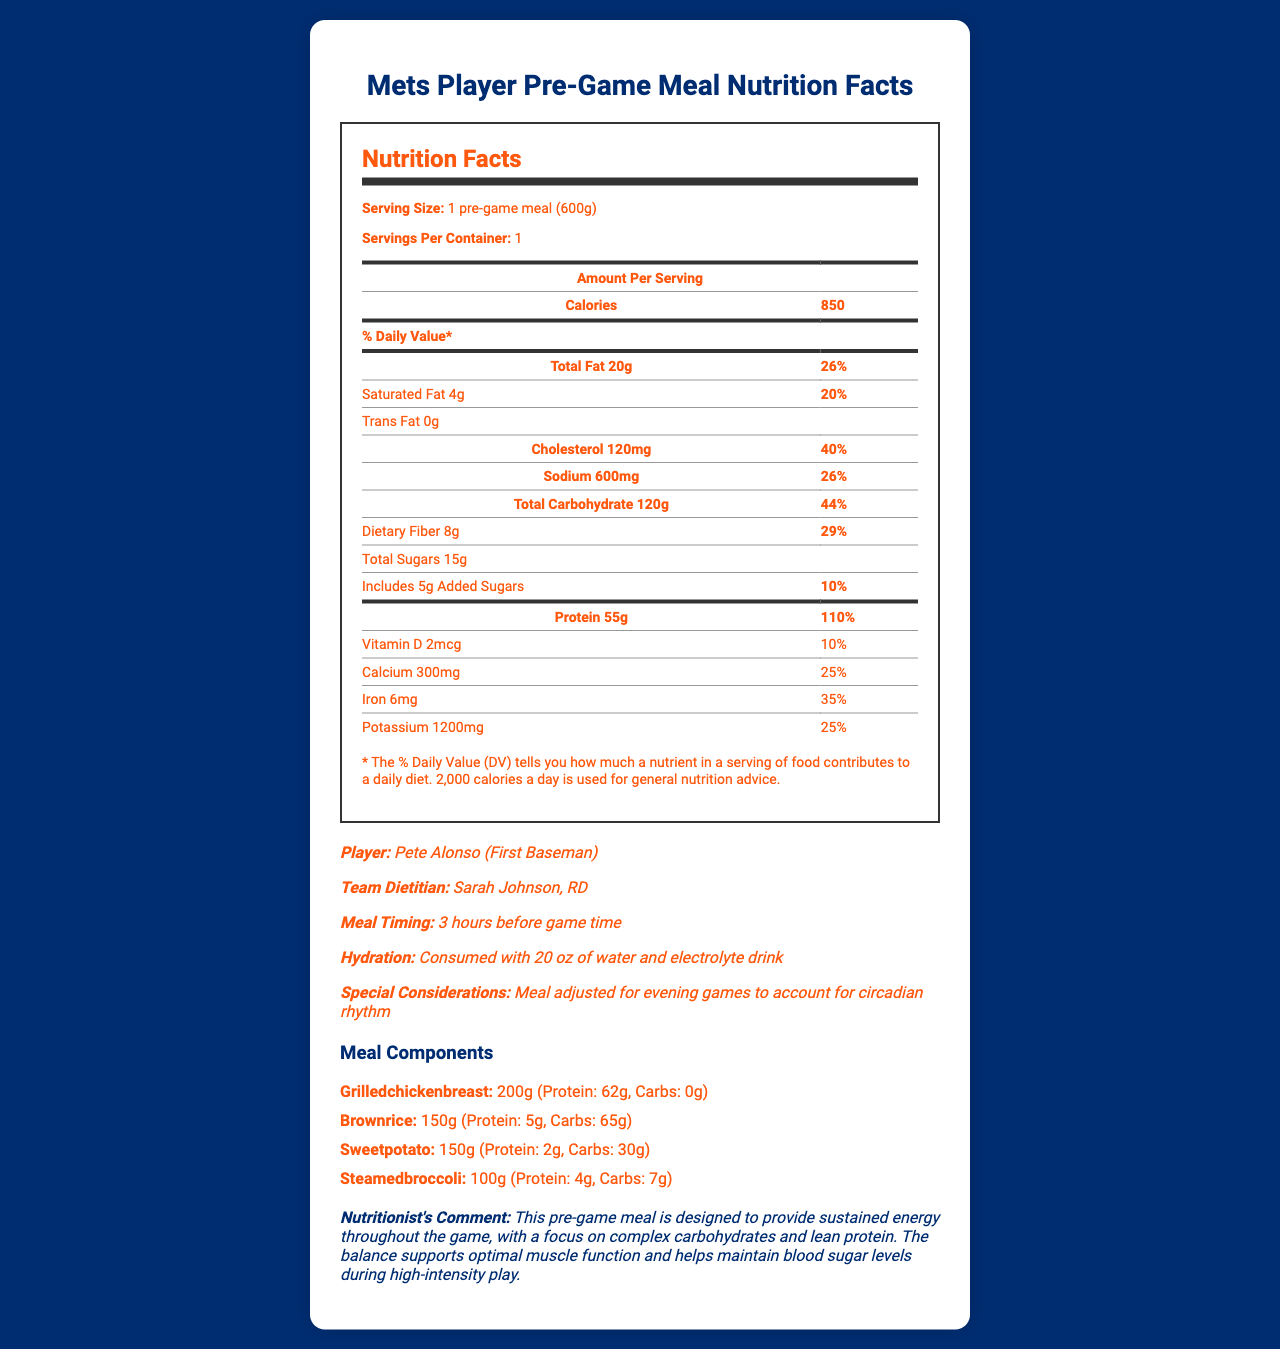who is the team dietitian listed in the document? The document specifies that the team dietitian is Sarah Johnson, RD.
Answer: Sarah Johnson, RD what is the serving size of the pre-game meal? The serving size is listed prominently at the beginning of the nutrition facts section as "1 pre-game meal (600g)".
Answer: 1 pre-game meal (600g) how much total fat does the meal contain? The total amount of fat is listed as 20g, and this is found in the Total Fat section of the nutrition label.
Answer: 20g what is the main source of protein in the meal? The meal components list shows that grilled chicken breast has the highest amount of protein at 62g.
Answer: Grilled chicken breast what is the average exit velocity of Pete Alonso according to the performance metrics? The average exit velocity is given in the performance metrics section as 92.5.
Answer: 92.5 how much total carbohydrate is in the pre-game meal? The total carbohydrate content is listed as 120g in the nutrition facts section.
Answer: 120g how many grams of dietary fiber are in the meal? A. 6g B. 8g C. 10g D. 12g According to the nutrition label, the dietary fiber content is 8g.
Answer: B what percentage of the daily value for protein does the meal provide? A. 55% B. 75% C. 110% D. 150% The document specifies that the protein content is 55g, which equates to 110% of the daily value.
Answer: C is the meal consumed before or after the game? The meal timing note states it is consumed 3 hours before game time.
Answer: Before summarize the main idea of the document. The document provides a comprehensive overview of the nutritional content of Pete Alonso's pre-game meal, emphasizing its design to support optimal performance, detailing the meal's components, timing, and hydration, as well as offering comments from the team dietitian.
Answer: The document details the nutritional breakdown of a typical pre-game meal for Mets player Pete Alonso. It focuses on the macronutrient and micronutrient content, highlights protein and carbohydrate sources, and gives insights into the meal’s purpose and adjustments. what are the names of the vegetables included in the meal? The meal components list includes steamed broccoli, but no other specific vegetables are mentioned. Therefore, it is not clear if there are other vegetables not listed.
Answer: Not enough information 